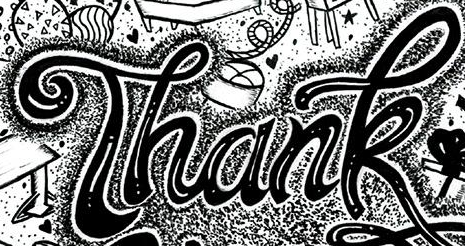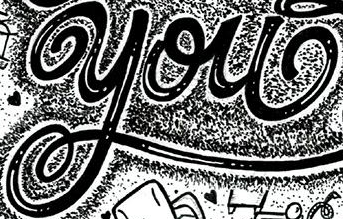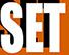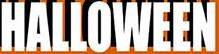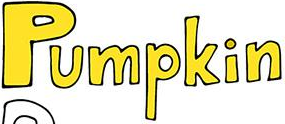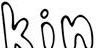What words are shown in these images in order, separated by a semicolon? Thank; you; SET; HALLOWEEN; Pumpkin; kin 